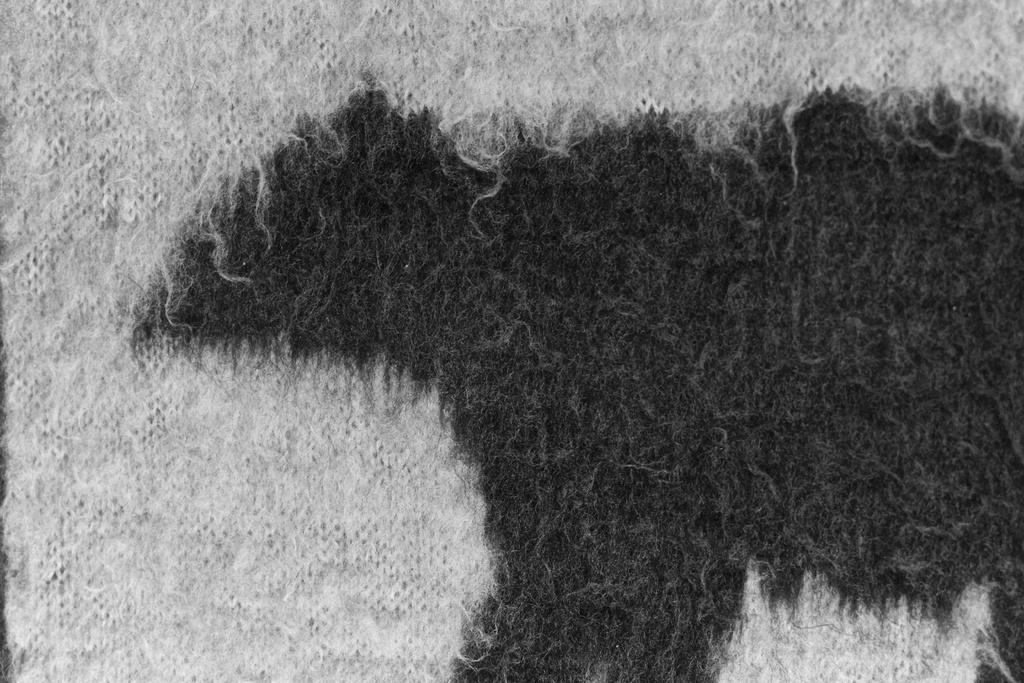What is present on the floor in the image? There is a mat in the image. What colors are used for the mat? The mat is in white and black color. What type of cheese is being advertised on the mat? There is no cheese or advertisement present on the mat; it is simply a white and black mat on the floor. 